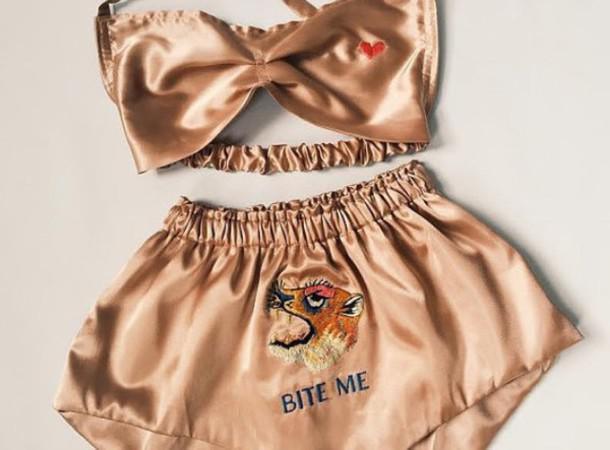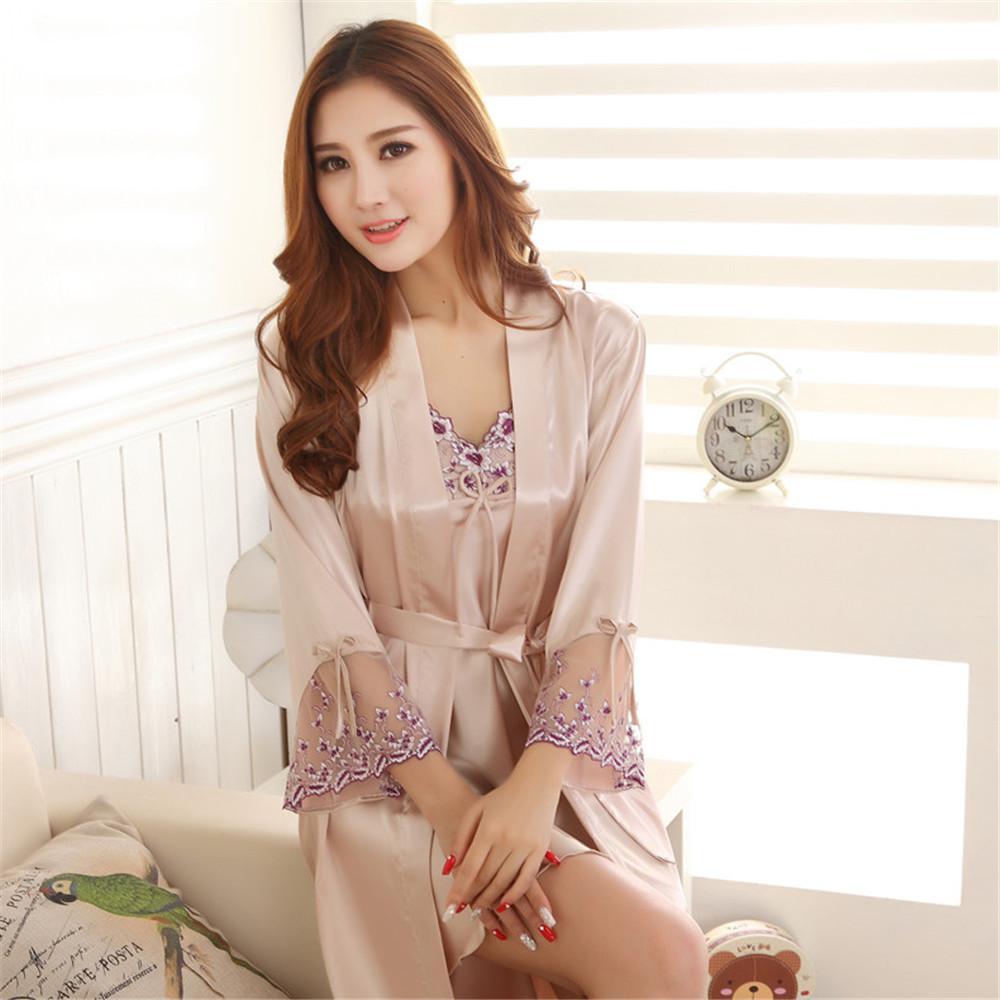The first image is the image on the left, the second image is the image on the right. Analyze the images presented: Is the assertion "In one image, a woman in lingerie is standing; and in the other image, a woman in lingerie is seated and smiling." valid? Answer yes or no. No. The first image is the image on the left, the second image is the image on the right. Analyze the images presented: Is the assertion "The image to the left features an asian woman." valid? Answer yes or no. No. 